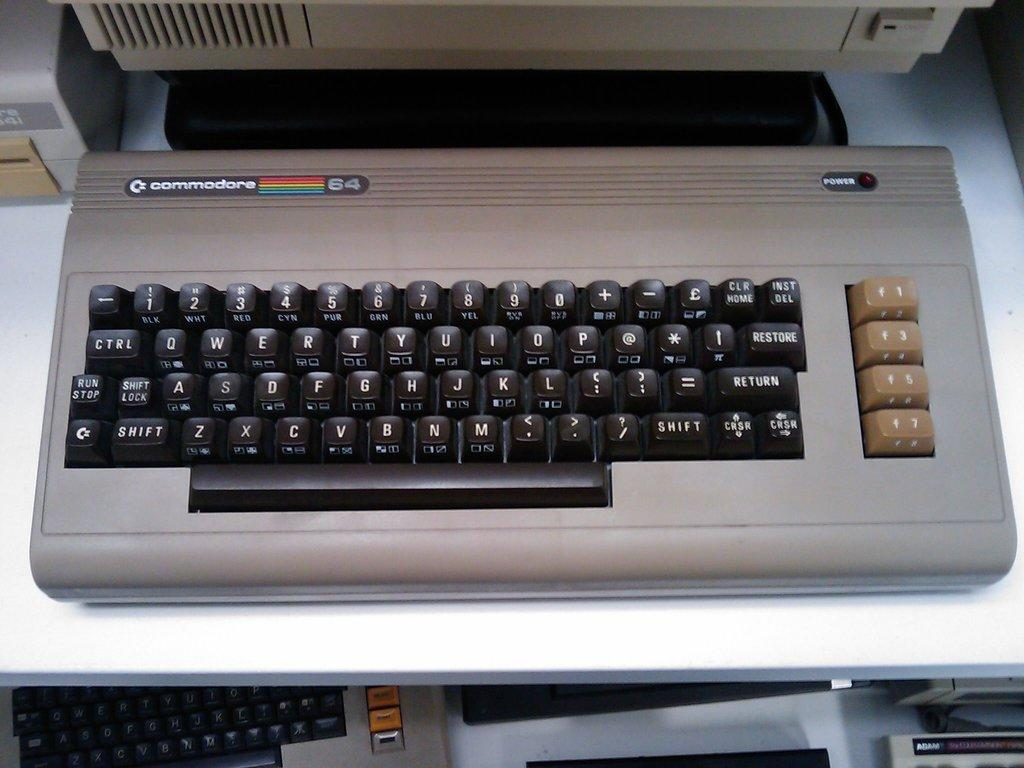<image>
Create a compact narrative representing the image presented. A Commodore computer keyboard with black with four function keys in tan on the side. 